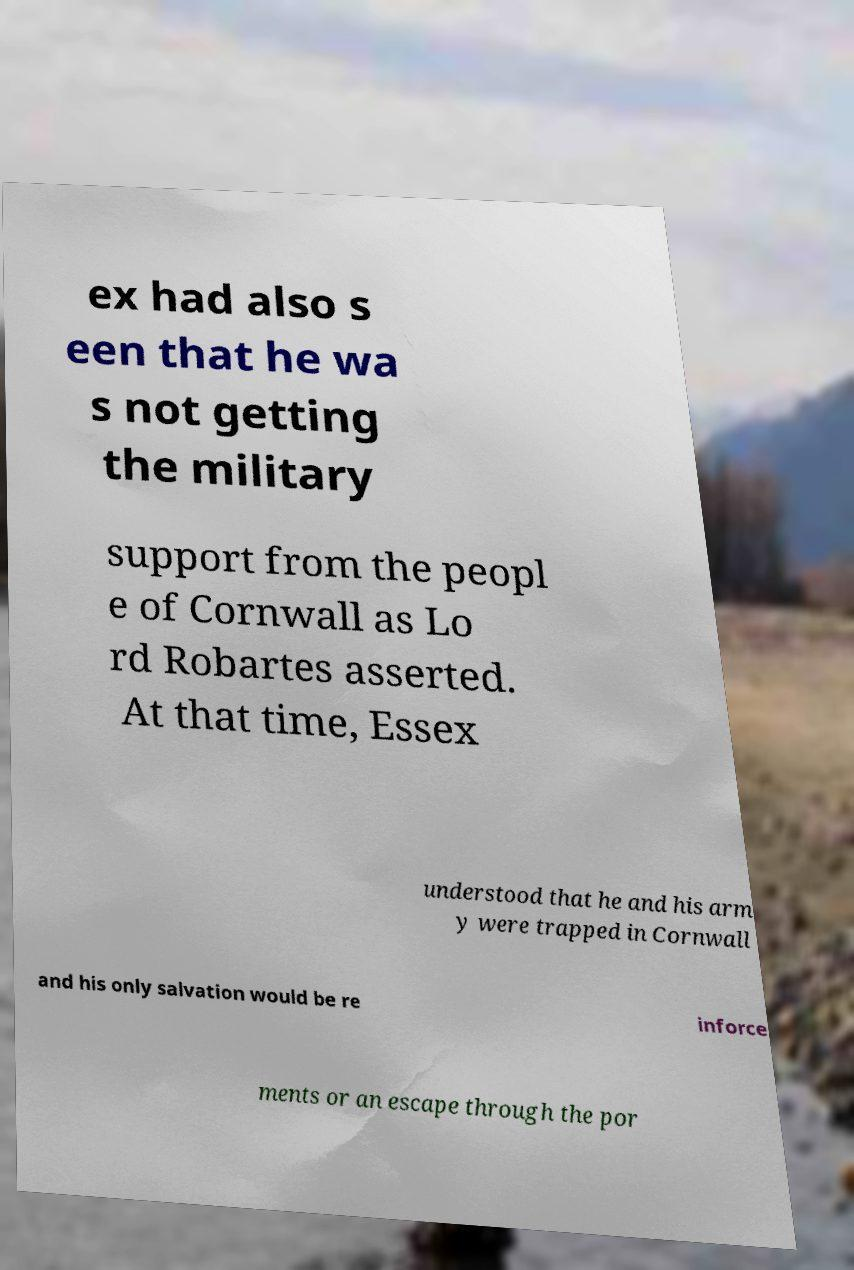For documentation purposes, I need the text within this image transcribed. Could you provide that? ex had also s een that he wa s not getting the military support from the peopl e of Cornwall as Lo rd Robartes asserted. At that time, Essex understood that he and his arm y were trapped in Cornwall and his only salvation would be re inforce ments or an escape through the por 